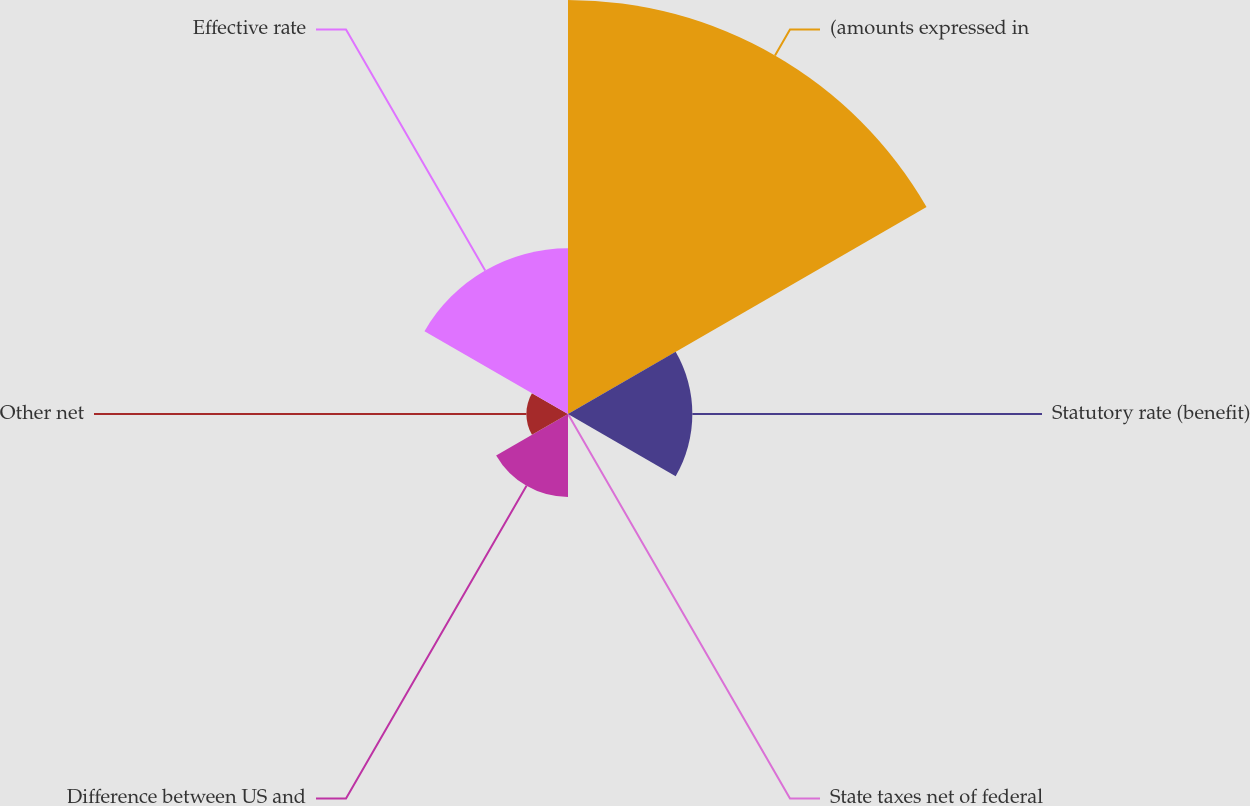<chart> <loc_0><loc_0><loc_500><loc_500><pie_chart><fcel>(amounts expressed in<fcel>Statutory rate (benefit)<fcel>State taxes net of federal<fcel>Difference between US and<fcel>Other net<fcel>Effective rate<nl><fcel>49.95%<fcel>15.0%<fcel>0.03%<fcel>10.01%<fcel>5.02%<fcel>19.99%<nl></chart> 